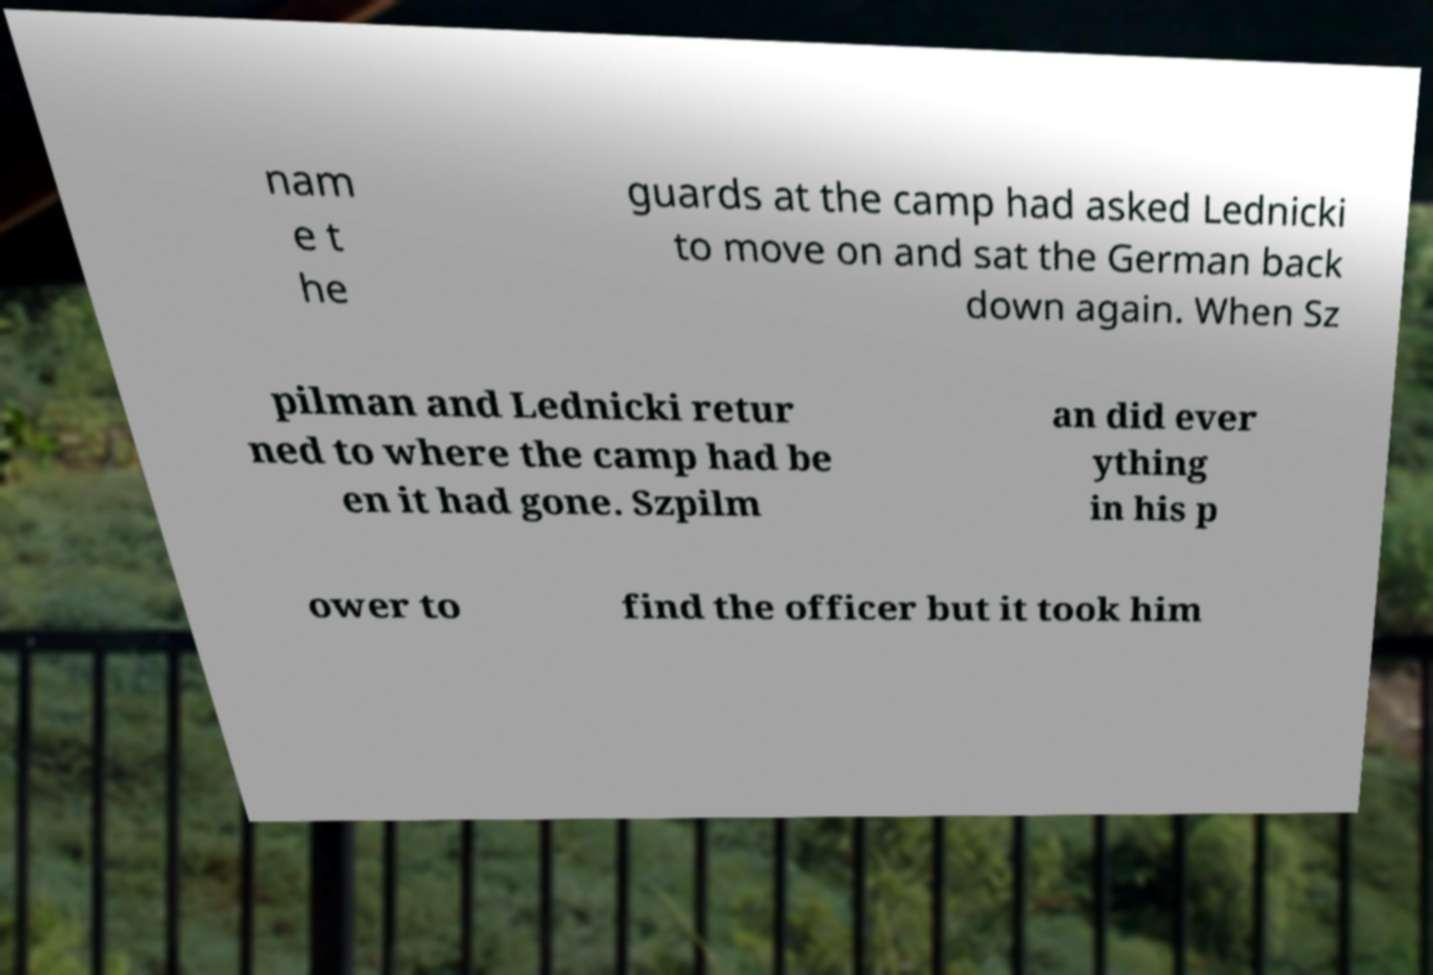I need the written content from this picture converted into text. Can you do that? nam e t he guards at the camp had asked Lednicki to move on and sat the German back down again. When Sz pilman and Lednicki retur ned to where the camp had be en it had gone. Szpilm an did ever ything in his p ower to find the officer but it took him 